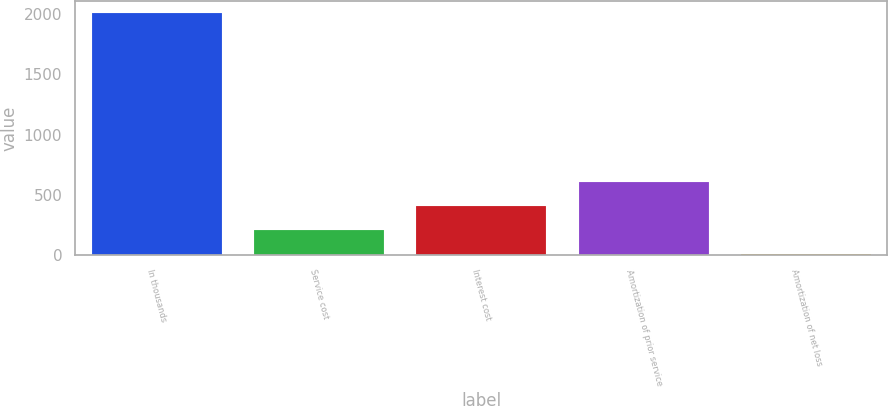Convert chart to OTSL. <chart><loc_0><loc_0><loc_500><loc_500><bar_chart><fcel>In thousands<fcel>Service cost<fcel>Interest cost<fcel>Amortization of prior service<fcel>Amortization of net loss<nl><fcel>2008<fcel>208.9<fcel>408.8<fcel>608.7<fcel>9<nl></chart> 